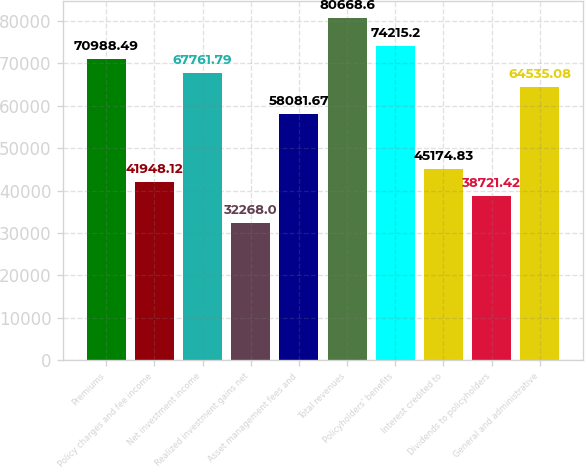<chart> <loc_0><loc_0><loc_500><loc_500><bar_chart><fcel>Premiums<fcel>Policy charges and fee income<fcel>Net investment income<fcel>Realized investment gains net<fcel>Asset management fees and<fcel>Total revenues<fcel>Policyholders' benefits<fcel>Interest credited to<fcel>Dividends to policyholders<fcel>General and administrative<nl><fcel>70988.5<fcel>41948.1<fcel>67761.8<fcel>32268<fcel>58081.7<fcel>80668.6<fcel>74215.2<fcel>45174.8<fcel>38721.4<fcel>64535.1<nl></chart> 